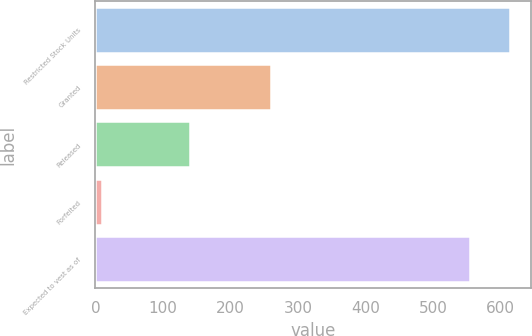Convert chart to OTSL. <chart><loc_0><loc_0><loc_500><loc_500><bar_chart><fcel>Restricted Stock Units<fcel>Granted<fcel>Released<fcel>Forfeited<fcel>Expected to vest as of<nl><fcel>614<fcel>260<fcel>140<fcel>10<fcel>554.5<nl></chart> 